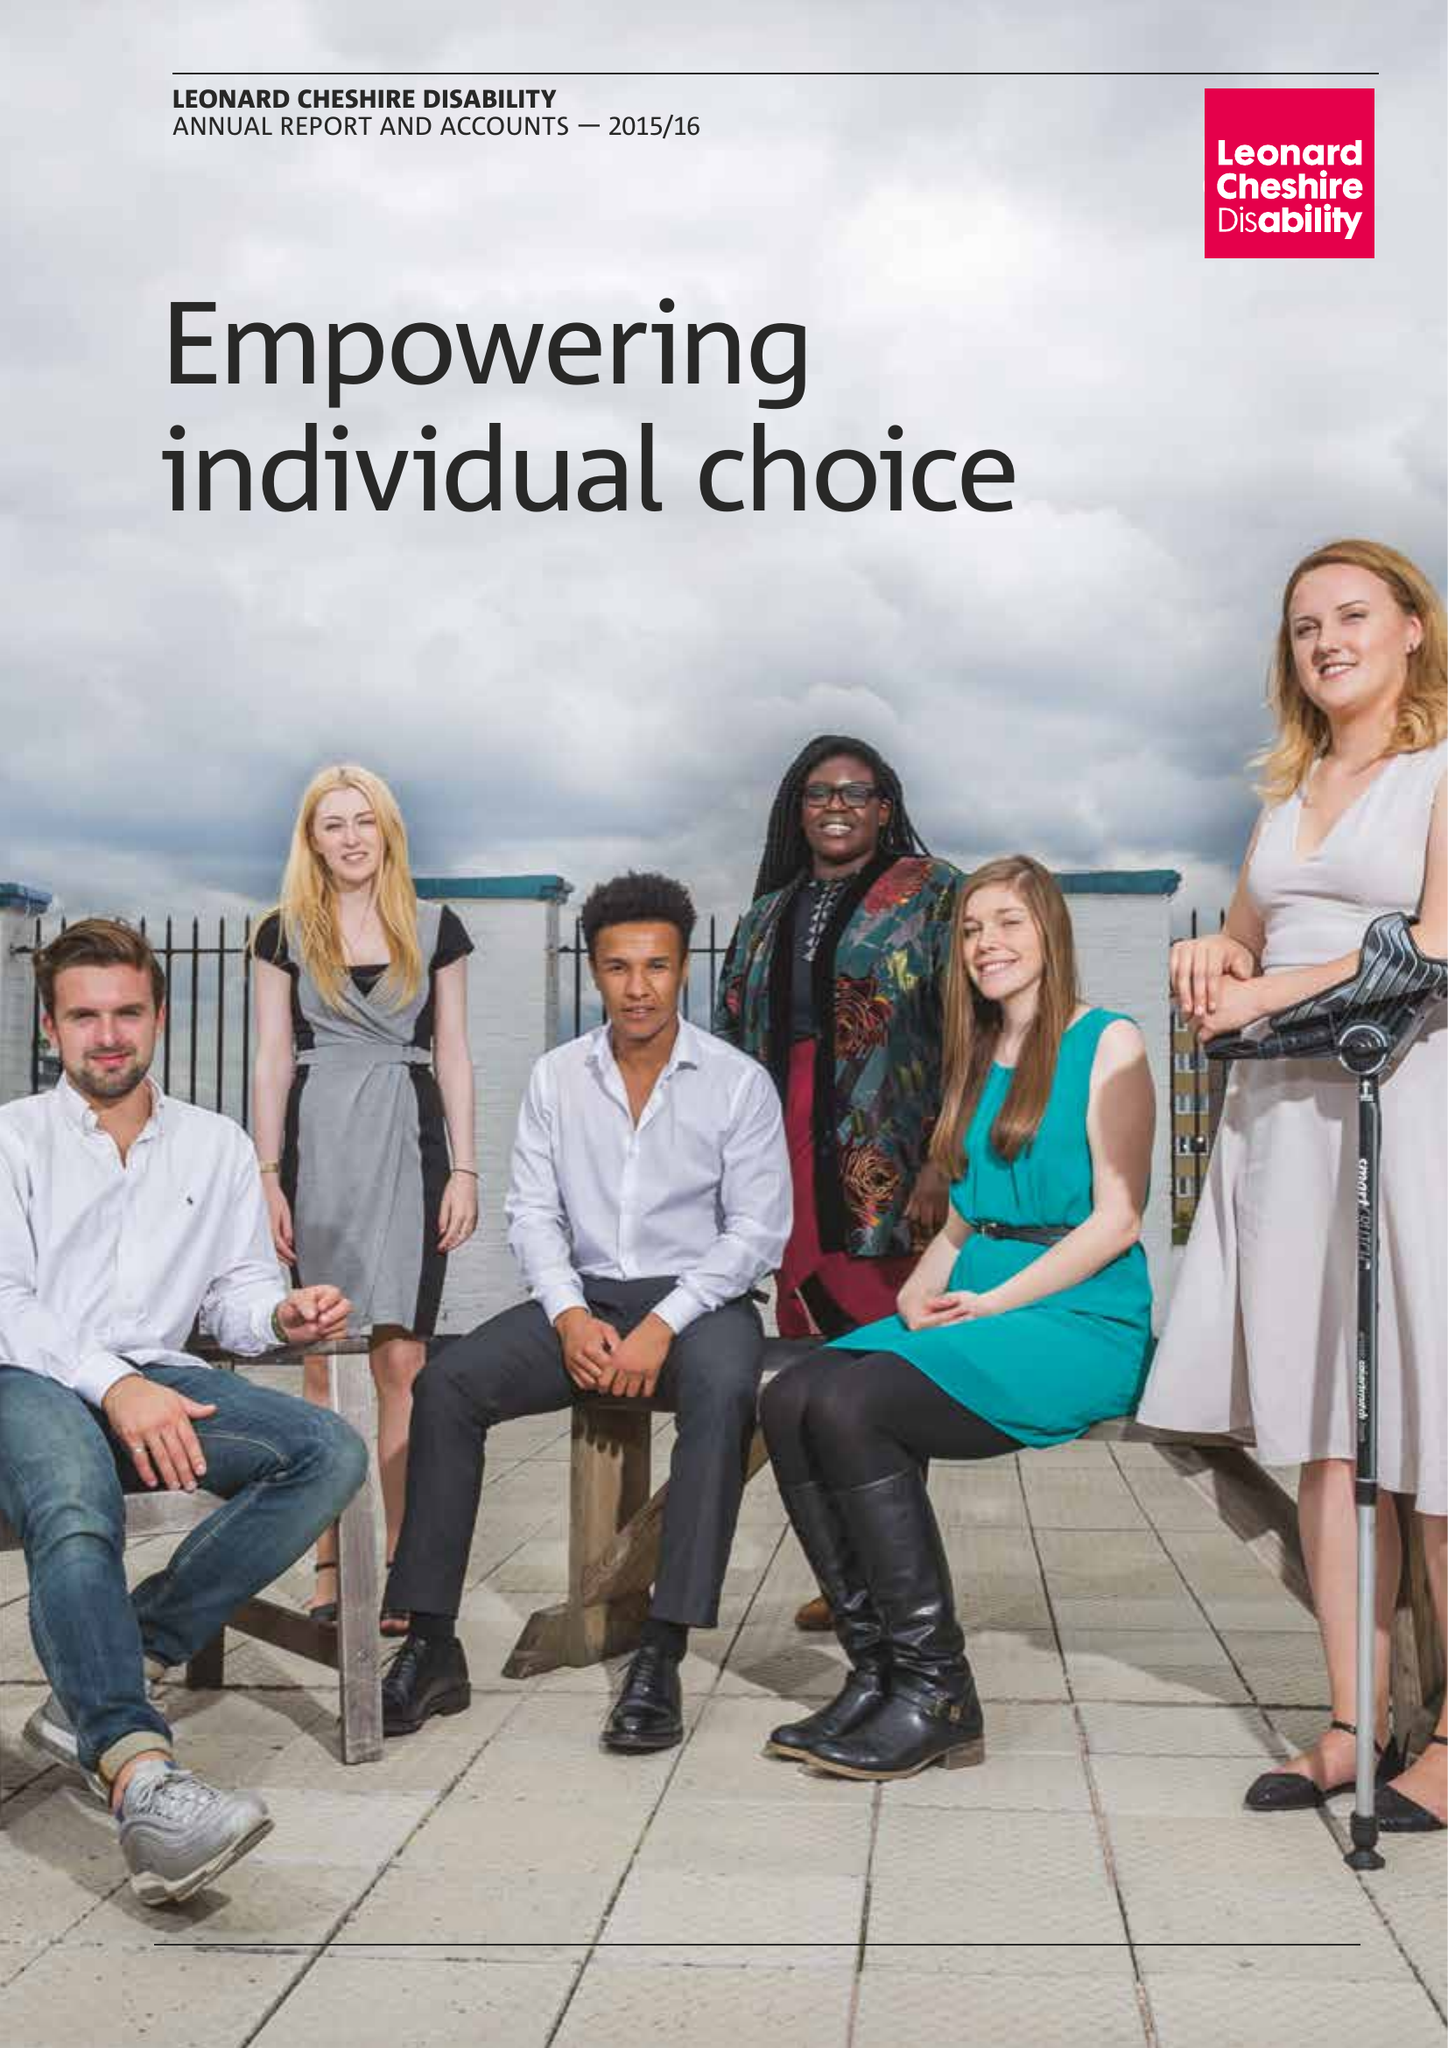What is the value for the address__postcode?
Answer the question using a single word or phrase. SW8 1RL 